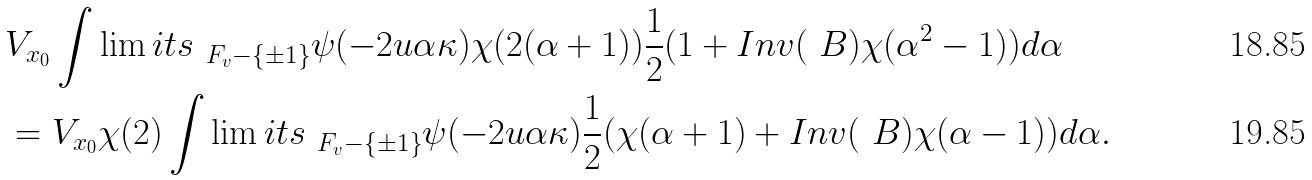Convert formula to latex. <formula><loc_0><loc_0><loc_500><loc_500>& V _ { x _ { 0 } } \int \lim i t s _ { \ F _ { v } - \{ \pm 1 \} } \psi ( - 2 u \alpha \kappa ) \chi ( 2 ( \alpha + 1 ) ) \frac { 1 } { 2 } ( 1 + I n v ( \ B ) \chi ( \alpha ^ { 2 } - 1 ) ) d \alpha \\ & = V _ { x _ { 0 } } \chi ( 2 ) \int \lim i t s _ { \ F _ { v } - \{ \pm 1 \} } \psi ( - 2 u \alpha \kappa ) \frac { 1 } { 2 } ( \chi ( \alpha + 1 ) + I n v ( \ B ) \chi ( \alpha - 1 ) ) d \alpha .</formula> 